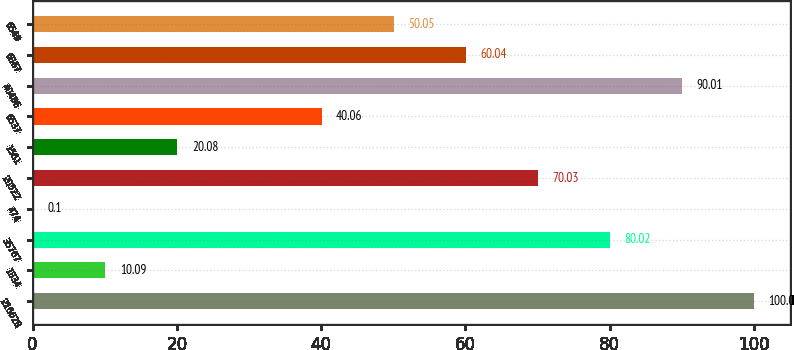Convert chart. <chart><loc_0><loc_0><loc_500><loc_500><bar_chart><fcel>216628<fcel>1834<fcel>35767<fcel>474<fcel>20522<fcel>1561<fcel>6537<fcel>40486<fcel>6867<fcel>6549<nl><fcel>100<fcel>10.09<fcel>80.02<fcel>0.1<fcel>70.03<fcel>20.08<fcel>40.06<fcel>90.01<fcel>60.04<fcel>50.05<nl></chart> 